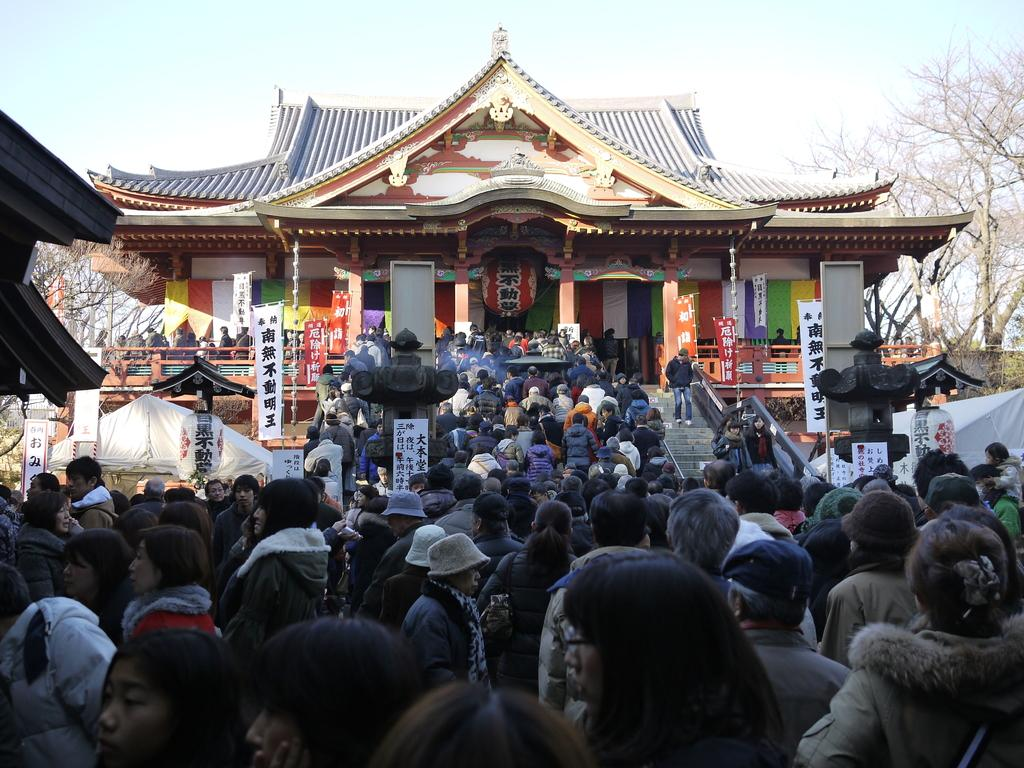What are the people in the image doing? The people in the image are standing and walking. What can be seen hanging or displayed in the image? There are banners visible in the image. What is visible in the background of the image? There are buildings and trees in the background of the image. What is visible at the top of the image? The sky is visible at the top of the image, and there are clouds visible in the sky. What type of dinner is being served in the image? There is no dinner present in the image; it features people standing and walking, banners, buildings, trees, and a sky with clouds. How many trains can be seen in the image? There are no trains visible in the image. 